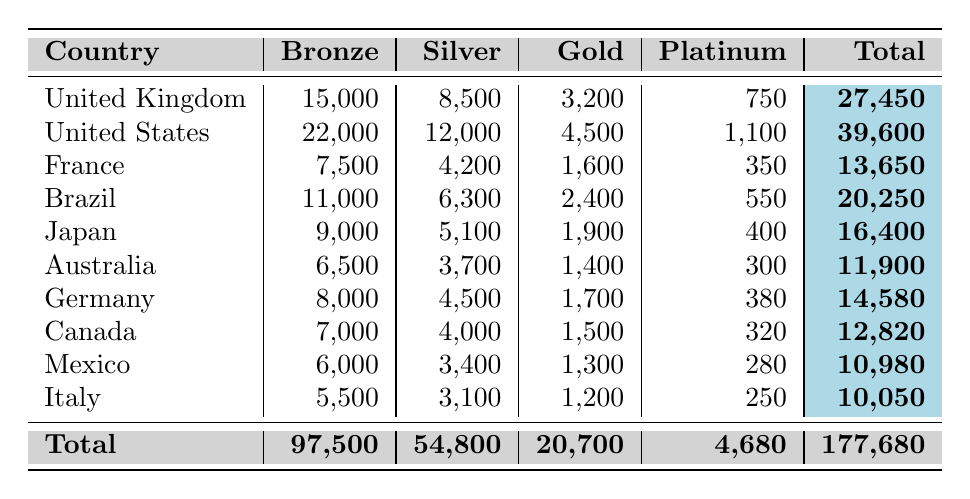What country has the highest number of Gold members? By reviewing the Gold category in the table, the United States has 4,500 Gold members, which is the highest compared to other countries.
Answer: United States What is the total number of Platinum members across all countries? To find the total number of Platinum members, we add all the Platinum members: 750 + 1100 + 350 + 550 + 400 + 300 + 380 + 320 + 280 + 250 = 4680.
Answer: 4680 Which country has the least number of Bronze members? Looking at the Bronze column, Italy has the lowest count with 5,500 members.
Answer: Italy How many more Silver members does the United States have compared to Germany? The United States has 12,000 Silver members while Germany has 4,500. The difference is 12,000 - 4,500 = 7,500 members.
Answer: 7500 Which country has the highest total number of members? By calculating the total for each country, the United States has the highest total with 39,600 members.
Answer: United States If we combine the Bronze and Silver memberships for Brazil, what is the total? Brazil has 11,000 Bronze and 6,300 Silver members. Adding these gives 11,000 + 6,300 = 17,300 members.
Answer: 17300 Is the number of Gold members in Japan greater than that in Australia? Japan has 1,900 Gold members while Australia has 1,400. Since 1,900 is greater than 1,400, the statement is true.
Answer: Yes What percentage of the total membership from France is Platinum? The total membership from France is 13,650, and there are 350 Platinum members. The percentage is (350 / 13650) * 100, which equals approximately 2.56%.
Answer: 2.56% How many more Bronze members does the United Kingdom have than Canada? The United Kingdom has 15,000 Bronze members and Canada has 7,000. The difference is 15,000 - 7,000 = 8,000 members.
Answer: 8000 What is the average number of Gold members across all countries? The Gold members for all countries sum up to 20,700, and there are 10 countries. Thus, the average is 20,700 / 10 = 2,070.
Answer: 2070 